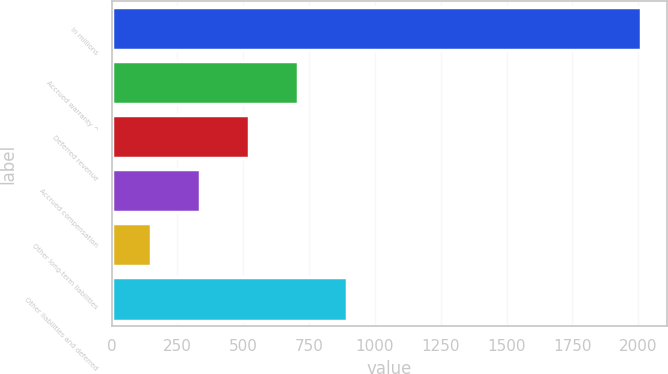<chart> <loc_0><loc_0><loc_500><loc_500><bar_chart><fcel>In millions<fcel>Accrued warranty ^<fcel>Deferred revenue<fcel>Accrued compensation<fcel>Other long-term liabilities<fcel>Other liabilities and deferred<nl><fcel>2010<fcel>706.6<fcel>520.4<fcel>334.2<fcel>148<fcel>892.8<nl></chart> 